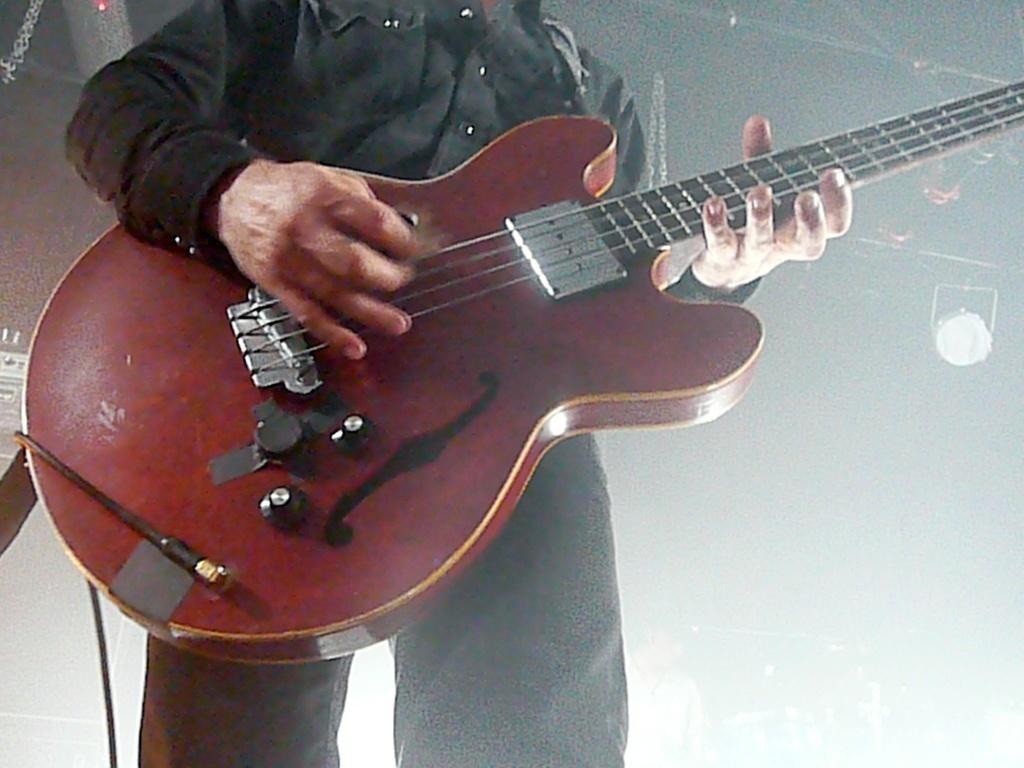Could you give a brief overview of what you see in this image? In this picture we can see man standing holding guitar in his hand and playing and in background we can see lights and it is blurry. 